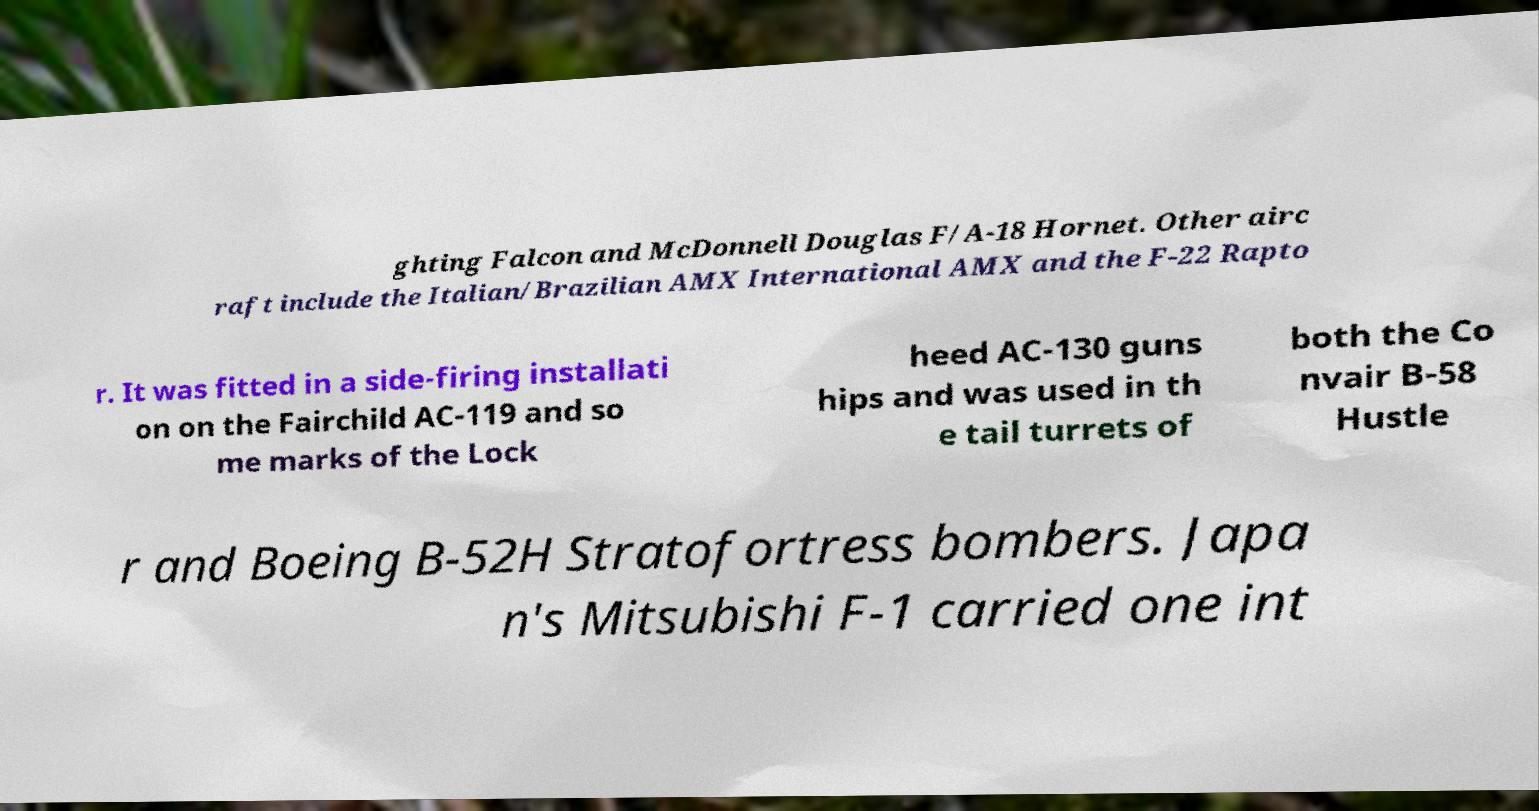Could you extract and type out the text from this image? ghting Falcon and McDonnell Douglas F/A-18 Hornet. Other airc raft include the Italian/Brazilian AMX International AMX and the F-22 Rapto r. It was fitted in a side-firing installati on on the Fairchild AC-119 and so me marks of the Lock heed AC-130 guns hips and was used in th e tail turrets of both the Co nvair B-58 Hustle r and Boeing B-52H Stratofortress bombers. Japa n's Mitsubishi F-1 carried one int 